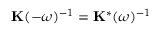Convert formula to latex. <formula><loc_0><loc_0><loc_500><loc_500>K ( - \omega ) ^ { - 1 } = K ^ { * } ( \omega ) ^ { - 1 }</formula> 